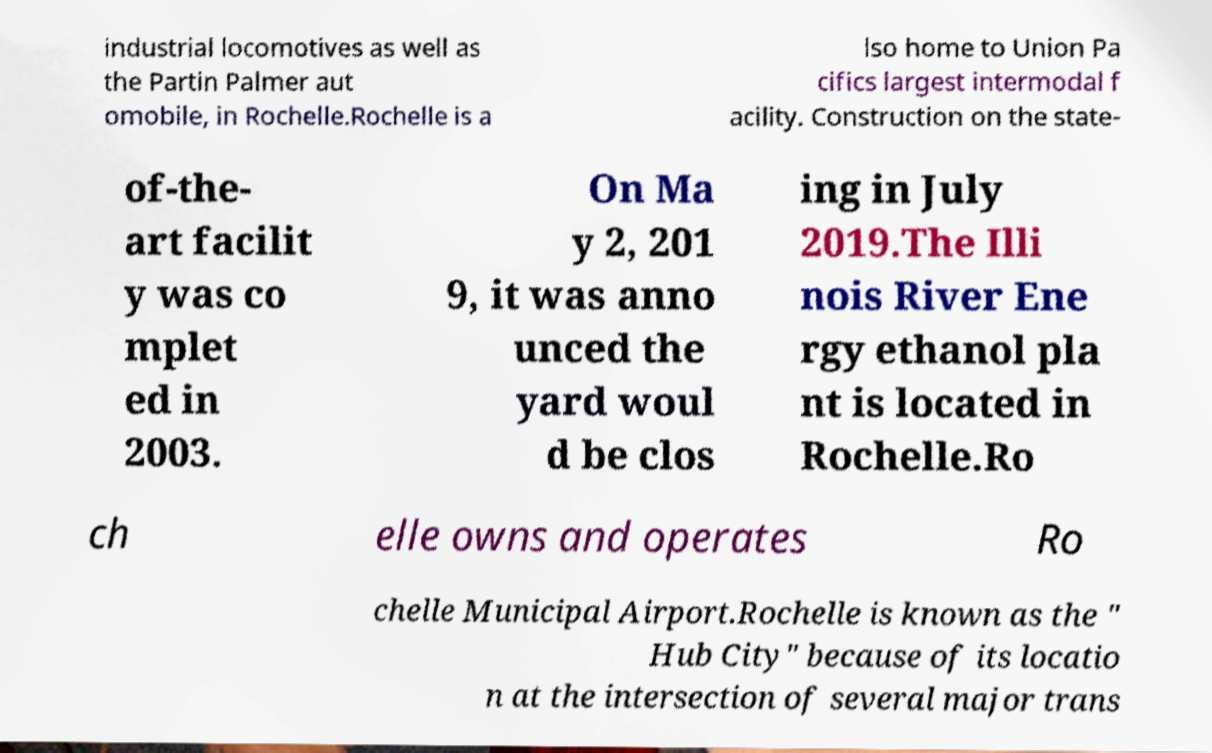Please identify and transcribe the text found in this image. industrial locomotives as well as the Partin Palmer aut omobile, in Rochelle.Rochelle is a lso home to Union Pa cifics largest intermodal f acility. Construction on the state- of-the- art facilit y was co mplet ed in 2003. On Ma y 2, 201 9, it was anno unced the yard woul d be clos ing in July 2019.The Illi nois River Ene rgy ethanol pla nt is located in Rochelle.Ro ch elle owns and operates Ro chelle Municipal Airport.Rochelle is known as the " Hub City" because of its locatio n at the intersection of several major trans 